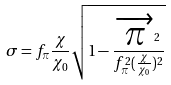<formula> <loc_0><loc_0><loc_500><loc_500>\sigma = f _ { \pi } \frac { \chi } { \chi _ { 0 } } \sqrt { 1 - \frac { \overrightarrow { \pi } ^ { 2 } } { f _ { \pi } ^ { 2 } ( \frac { \chi } { \chi _ { 0 } } ) ^ { 2 } } }</formula> 